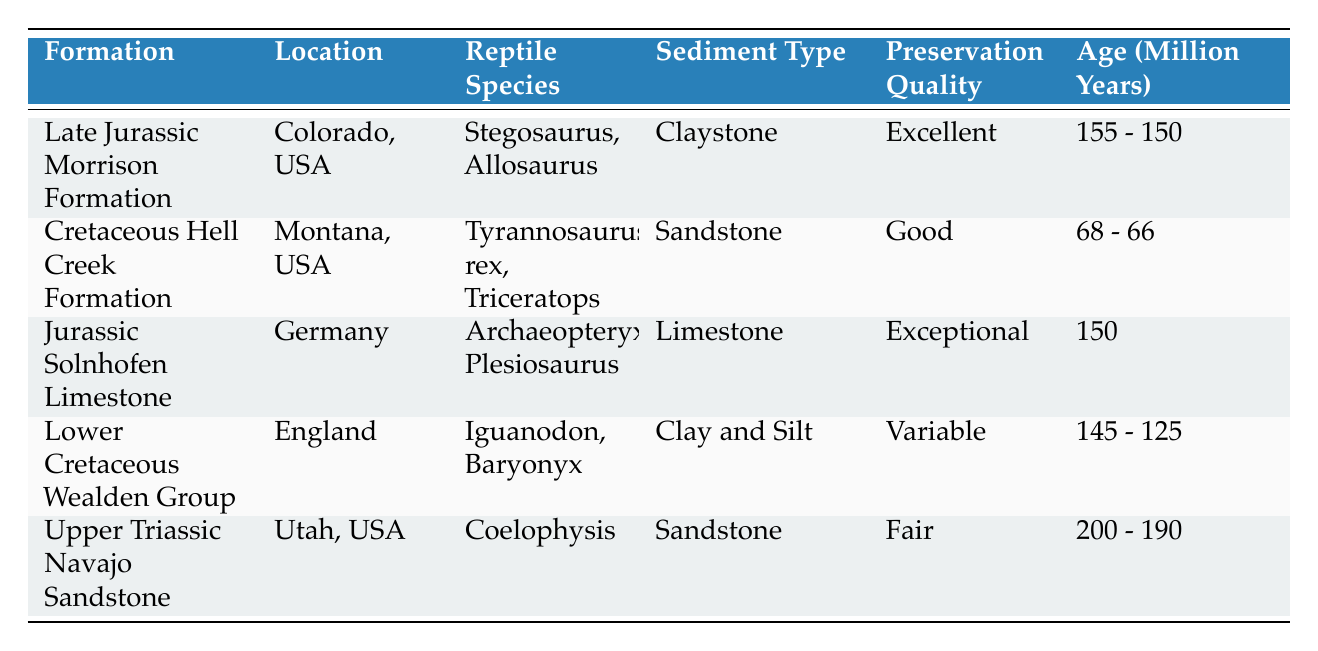What is the preservation quality of fossils from the Late Jurassic Morrison Formation? The table lists the preservation quality as "Excellent" for this formation.
Answer: Excellent Which geological formation has the oldest age range for fossils? The Upper Triassic Navajo Sandstone has the age range of 200 - 190 million years, making it the oldest among the listed formations.
Answer: Upper Triassic Navajo Sandstone How many different reptile species are found in the Cretaceous Hell Creek Formation? The table lists two species, Tyrannosaurus rex and Triceratops, for this formation.
Answer: 2 Is the preservation quality of fossils from the Jurassic Solnhofen Limestone better than that from the Lower Cretaceous Wealden Group? The Jurassic Solnhofen Limestone has "Exceptional" preservation quality, while the Lower Cretaceous Wealden Group is "Variable." Thus, yes, it is better.
Answer: Yes What is the sediment type in which the Iguanodon fossils were found? According to the table, the sediment type for Iguanodon is "Clay and Silt."
Answer: Clay and Silt In which formation were fossils preserved under "anoxic lagoon environment"? The Jurassic Solnhofen Limestone is the formation where fossils experienced this preservation process.
Answer: Jurassic Solnhofen Limestone If we consider all the formations listed, how many formations have a preservation quality of "Good" or better? There are four formations with quality "Excellent," "Exceptional," and "Good," which means four formations.
Answer: 4 Which two formations have sediment types that are both sandstone? The Cretaceous Hell Creek Formation and the Upper Triassic Navajo Sandstone both have "Sandstone" as their sediment type.
Answer: Cretaceous Hell Creek Formation and Upper Triassic Navajo Sandstone Is "Rapid burial and anoxic conditions" a preservation process used in the Late Jurassic Morrison Formation? Yes, the table specifies that this is indeed the preservation process for the Late Jurassic Morrison Formation.
Answer: Yes What is the age range of fossils found in the Cretaceous Hell Creek Formation compared to the Lower Cretaceous Wealden Group? The Cretaceous Hell Creek Formation has an age of 68 - 66 million years, while the Lower Cretaceous Wealden Group ranges from 145 - 125 million years which is older.
Answer: Lower Cretaceous Wealden Group is older 